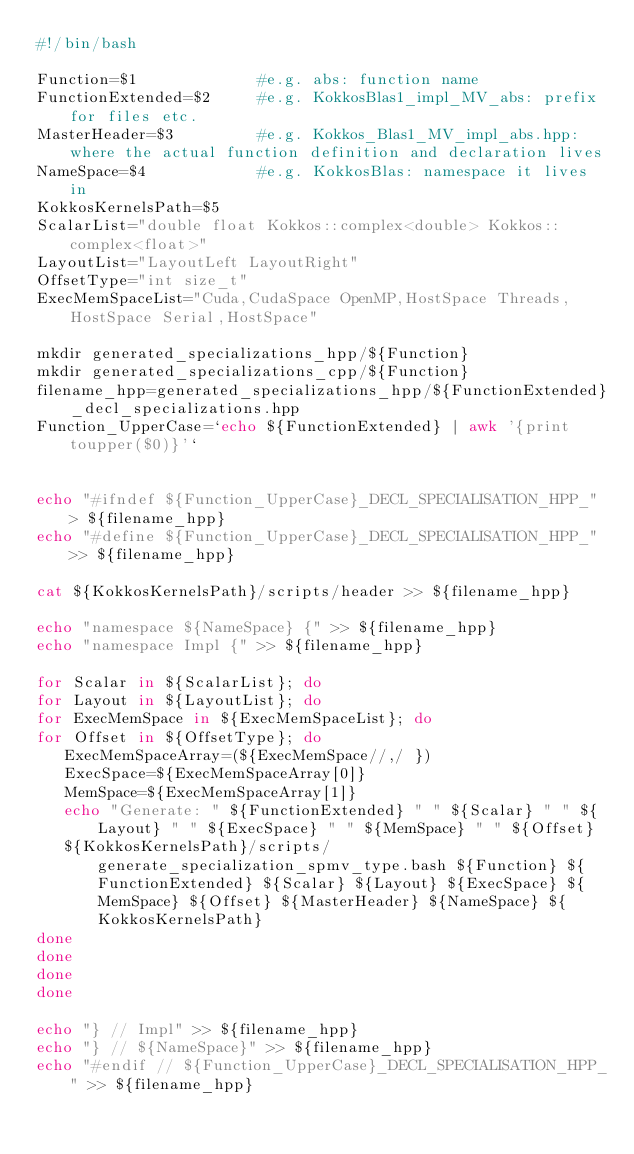<code> <loc_0><loc_0><loc_500><loc_500><_Bash_>#!/bin/bash

Function=$1             #e.g. abs: function name
FunctionExtended=$2     #e.g. KokkosBlas1_impl_MV_abs: prefix for files etc.
MasterHeader=$3         #e.g. Kokkos_Blas1_MV_impl_abs.hpp: where the actual function definition and declaration lives
NameSpace=$4            #e.g. KokkosBlas: namespace it lives in
KokkosKernelsPath=$5
ScalarList="double float Kokkos::complex<double> Kokkos::complex<float>"
LayoutList="LayoutLeft LayoutRight"
OffsetType="int size_t"
ExecMemSpaceList="Cuda,CudaSpace OpenMP,HostSpace Threads,HostSpace Serial,HostSpace"

mkdir generated_specializations_hpp/${Function}
mkdir generated_specializations_cpp/${Function}
filename_hpp=generated_specializations_hpp/${FunctionExtended}_decl_specializations.hpp
Function_UpperCase=`echo ${FunctionExtended} | awk '{print toupper($0)}'`


echo "#ifndef ${Function_UpperCase}_DECL_SPECIALISATION_HPP_" > ${filename_hpp}
echo "#define ${Function_UpperCase}_DECL_SPECIALISATION_HPP_" >> ${filename_hpp}

cat ${KokkosKernelsPath}/scripts/header >> ${filename_hpp}

echo "namespace ${NameSpace} {" >> ${filename_hpp}
echo "namespace Impl {" >> ${filename_hpp}

for Scalar in ${ScalarList}; do
for Layout in ${LayoutList}; do
for ExecMemSpace in ${ExecMemSpaceList}; do
for Offset in ${OffsetType}; do
   ExecMemSpaceArray=(${ExecMemSpace//,/ })
   ExecSpace=${ExecMemSpaceArray[0]}
   MemSpace=${ExecMemSpaceArray[1]}
   echo "Generate: " ${FunctionExtended} " " ${Scalar} " " ${Layout} " " ${ExecSpace} " " ${MemSpace} " " ${Offset}
   ${KokkosKernelsPath}/scripts/generate_specialization_spmv_type.bash ${Function} ${FunctionExtended} ${Scalar} ${Layout} ${ExecSpace} ${MemSpace} ${Offset} ${MasterHeader} ${NameSpace} ${KokkosKernelsPath}
done
done
done
done

echo "} // Impl" >> ${filename_hpp}
echo "} // ${NameSpace}" >> ${filename_hpp}
echo "#endif // ${Function_UpperCase}_DECL_SPECIALISATION_HPP_" >> ${filename_hpp}
</code> 